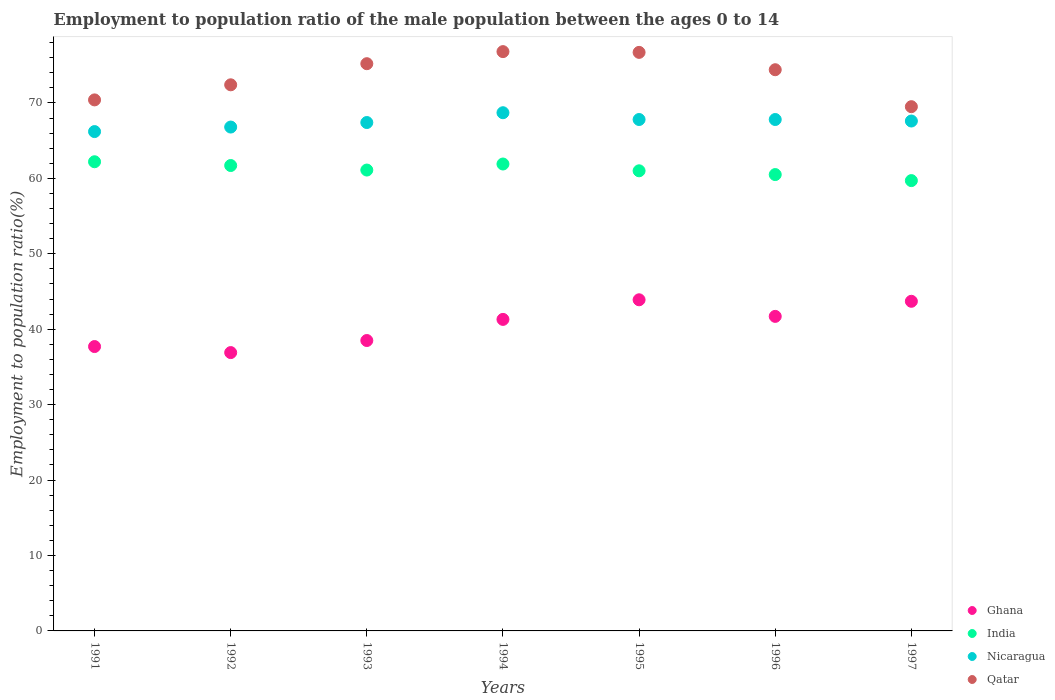How many different coloured dotlines are there?
Provide a short and direct response. 4. Is the number of dotlines equal to the number of legend labels?
Ensure brevity in your answer.  Yes. What is the employment to population ratio in Nicaragua in 1993?
Make the answer very short. 67.4. Across all years, what is the maximum employment to population ratio in Ghana?
Your response must be concise. 43.9. Across all years, what is the minimum employment to population ratio in Qatar?
Provide a succinct answer. 69.5. In which year was the employment to population ratio in India maximum?
Offer a terse response. 1991. In which year was the employment to population ratio in Ghana minimum?
Offer a very short reply. 1992. What is the total employment to population ratio in India in the graph?
Give a very brief answer. 428.1. What is the difference between the employment to population ratio in Qatar in 1992 and that in 1993?
Your response must be concise. -2.8. What is the difference between the employment to population ratio in Qatar in 1994 and the employment to population ratio in Ghana in 1997?
Provide a short and direct response. 33.1. What is the average employment to population ratio in Nicaragua per year?
Provide a short and direct response. 67.47. In the year 1997, what is the difference between the employment to population ratio in Ghana and employment to population ratio in India?
Give a very brief answer. -16. In how many years, is the employment to population ratio in Ghana greater than 4 %?
Keep it short and to the point. 7. What is the ratio of the employment to population ratio in Ghana in 1992 to that in 1994?
Your response must be concise. 0.89. Is the employment to population ratio in India in 1993 less than that in 1997?
Give a very brief answer. No. Is the difference between the employment to population ratio in Ghana in 1992 and 1996 greater than the difference between the employment to population ratio in India in 1992 and 1996?
Keep it short and to the point. No. What is the difference between the highest and the second highest employment to population ratio in Qatar?
Give a very brief answer. 0.1. Does the employment to population ratio in India monotonically increase over the years?
Your answer should be very brief. No. Is the employment to population ratio in Nicaragua strictly less than the employment to population ratio in Ghana over the years?
Your answer should be compact. No. What is the difference between two consecutive major ticks on the Y-axis?
Your answer should be compact. 10. Are the values on the major ticks of Y-axis written in scientific E-notation?
Your answer should be compact. No. Does the graph contain any zero values?
Your answer should be very brief. No. Does the graph contain grids?
Your answer should be compact. No. How many legend labels are there?
Offer a terse response. 4. How are the legend labels stacked?
Give a very brief answer. Vertical. What is the title of the graph?
Offer a terse response. Employment to population ratio of the male population between the ages 0 to 14. What is the label or title of the X-axis?
Ensure brevity in your answer.  Years. What is the label or title of the Y-axis?
Offer a very short reply. Employment to population ratio(%). What is the Employment to population ratio(%) of Ghana in 1991?
Offer a very short reply. 37.7. What is the Employment to population ratio(%) in India in 1991?
Your answer should be compact. 62.2. What is the Employment to population ratio(%) of Nicaragua in 1991?
Your answer should be compact. 66.2. What is the Employment to population ratio(%) in Qatar in 1991?
Your answer should be compact. 70.4. What is the Employment to population ratio(%) in Ghana in 1992?
Your answer should be compact. 36.9. What is the Employment to population ratio(%) in India in 1992?
Make the answer very short. 61.7. What is the Employment to population ratio(%) in Nicaragua in 1992?
Provide a short and direct response. 66.8. What is the Employment to population ratio(%) in Qatar in 1992?
Keep it short and to the point. 72.4. What is the Employment to population ratio(%) in Ghana in 1993?
Offer a very short reply. 38.5. What is the Employment to population ratio(%) of India in 1993?
Your answer should be compact. 61.1. What is the Employment to population ratio(%) in Nicaragua in 1993?
Your answer should be compact. 67.4. What is the Employment to population ratio(%) in Qatar in 1993?
Keep it short and to the point. 75.2. What is the Employment to population ratio(%) of Ghana in 1994?
Provide a short and direct response. 41.3. What is the Employment to population ratio(%) of India in 1994?
Make the answer very short. 61.9. What is the Employment to population ratio(%) in Nicaragua in 1994?
Offer a very short reply. 68.7. What is the Employment to population ratio(%) of Qatar in 1994?
Ensure brevity in your answer.  76.8. What is the Employment to population ratio(%) of Ghana in 1995?
Offer a terse response. 43.9. What is the Employment to population ratio(%) in Nicaragua in 1995?
Your answer should be compact. 67.8. What is the Employment to population ratio(%) in Qatar in 1995?
Keep it short and to the point. 76.7. What is the Employment to population ratio(%) in Ghana in 1996?
Provide a succinct answer. 41.7. What is the Employment to population ratio(%) of India in 1996?
Give a very brief answer. 60.5. What is the Employment to population ratio(%) of Nicaragua in 1996?
Ensure brevity in your answer.  67.8. What is the Employment to population ratio(%) of Qatar in 1996?
Offer a very short reply. 74.4. What is the Employment to population ratio(%) of Ghana in 1997?
Make the answer very short. 43.7. What is the Employment to population ratio(%) in India in 1997?
Offer a very short reply. 59.7. What is the Employment to population ratio(%) in Nicaragua in 1997?
Give a very brief answer. 67.6. What is the Employment to population ratio(%) in Qatar in 1997?
Your answer should be compact. 69.5. Across all years, what is the maximum Employment to population ratio(%) in Ghana?
Your answer should be very brief. 43.9. Across all years, what is the maximum Employment to population ratio(%) in India?
Provide a short and direct response. 62.2. Across all years, what is the maximum Employment to population ratio(%) in Nicaragua?
Make the answer very short. 68.7. Across all years, what is the maximum Employment to population ratio(%) of Qatar?
Provide a succinct answer. 76.8. Across all years, what is the minimum Employment to population ratio(%) in Ghana?
Your response must be concise. 36.9. Across all years, what is the minimum Employment to population ratio(%) of India?
Provide a succinct answer. 59.7. Across all years, what is the minimum Employment to population ratio(%) in Nicaragua?
Provide a short and direct response. 66.2. Across all years, what is the minimum Employment to population ratio(%) of Qatar?
Provide a short and direct response. 69.5. What is the total Employment to population ratio(%) in Ghana in the graph?
Offer a terse response. 283.7. What is the total Employment to population ratio(%) of India in the graph?
Make the answer very short. 428.1. What is the total Employment to population ratio(%) of Nicaragua in the graph?
Ensure brevity in your answer.  472.3. What is the total Employment to population ratio(%) of Qatar in the graph?
Provide a succinct answer. 515.4. What is the difference between the Employment to population ratio(%) in Ghana in 1991 and that in 1992?
Make the answer very short. 0.8. What is the difference between the Employment to population ratio(%) in Nicaragua in 1991 and that in 1992?
Your response must be concise. -0.6. What is the difference between the Employment to population ratio(%) in Qatar in 1991 and that in 1992?
Offer a very short reply. -2. What is the difference between the Employment to population ratio(%) of Ghana in 1991 and that in 1993?
Give a very brief answer. -0.8. What is the difference between the Employment to population ratio(%) of India in 1991 and that in 1993?
Give a very brief answer. 1.1. What is the difference between the Employment to population ratio(%) of Nicaragua in 1991 and that in 1993?
Your response must be concise. -1.2. What is the difference between the Employment to population ratio(%) in India in 1991 and that in 1994?
Provide a short and direct response. 0.3. What is the difference between the Employment to population ratio(%) of Nicaragua in 1991 and that in 1994?
Give a very brief answer. -2.5. What is the difference between the Employment to population ratio(%) in Ghana in 1991 and that in 1995?
Your answer should be very brief. -6.2. What is the difference between the Employment to population ratio(%) of India in 1991 and that in 1995?
Offer a very short reply. 1.2. What is the difference between the Employment to population ratio(%) of Nicaragua in 1991 and that in 1995?
Provide a short and direct response. -1.6. What is the difference between the Employment to population ratio(%) of Qatar in 1991 and that in 1996?
Offer a very short reply. -4. What is the difference between the Employment to population ratio(%) in Ghana in 1991 and that in 1997?
Your response must be concise. -6. What is the difference between the Employment to population ratio(%) in Nicaragua in 1991 and that in 1997?
Your response must be concise. -1.4. What is the difference between the Employment to population ratio(%) in Qatar in 1991 and that in 1997?
Make the answer very short. 0.9. What is the difference between the Employment to population ratio(%) of India in 1992 and that in 1993?
Give a very brief answer. 0.6. What is the difference between the Employment to population ratio(%) in Nicaragua in 1992 and that in 1993?
Make the answer very short. -0.6. What is the difference between the Employment to population ratio(%) in Ghana in 1992 and that in 1994?
Your answer should be very brief. -4.4. What is the difference between the Employment to population ratio(%) of Nicaragua in 1992 and that in 1994?
Your answer should be very brief. -1.9. What is the difference between the Employment to population ratio(%) of Ghana in 1992 and that in 1995?
Offer a very short reply. -7. What is the difference between the Employment to population ratio(%) of India in 1992 and that in 1995?
Make the answer very short. 0.7. What is the difference between the Employment to population ratio(%) in Qatar in 1992 and that in 1995?
Keep it short and to the point. -4.3. What is the difference between the Employment to population ratio(%) in India in 1992 and that in 1996?
Give a very brief answer. 1.2. What is the difference between the Employment to population ratio(%) of Nicaragua in 1992 and that in 1996?
Your response must be concise. -1. What is the difference between the Employment to population ratio(%) in Nicaragua in 1992 and that in 1997?
Ensure brevity in your answer.  -0.8. What is the difference between the Employment to population ratio(%) of Ghana in 1993 and that in 1994?
Give a very brief answer. -2.8. What is the difference between the Employment to population ratio(%) in India in 1993 and that in 1994?
Your answer should be compact. -0.8. What is the difference between the Employment to population ratio(%) in Nicaragua in 1993 and that in 1994?
Offer a very short reply. -1.3. What is the difference between the Employment to population ratio(%) of Qatar in 1993 and that in 1994?
Your answer should be compact. -1.6. What is the difference between the Employment to population ratio(%) in India in 1993 and that in 1995?
Your response must be concise. 0.1. What is the difference between the Employment to population ratio(%) in Nicaragua in 1993 and that in 1995?
Offer a terse response. -0.4. What is the difference between the Employment to population ratio(%) in Ghana in 1993 and that in 1996?
Make the answer very short. -3.2. What is the difference between the Employment to population ratio(%) in India in 1993 and that in 1996?
Your response must be concise. 0.6. What is the difference between the Employment to population ratio(%) in Qatar in 1993 and that in 1996?
Ensure brevity in your answer.  0.8. What is the difference between the Employment to population ratio(%) in Ghana in 1993 and that in 1997?
Provide a succinct answer. -5.2. What is the difference between the Employment to population ratio(%) of Qatar in 1993 and that in 1997?
Give a very brief answer. 5.7. What is the difference between the Employment to population ratio(%) in Ghana in 1994 and that in 1995?
Your answer should be compact. -2.6. What is the difference between the Employment to population ratio(%) of Nicaragua in 1994 and that in 1995?
Ensure brevity in your answer.  0.9. What is the difference between the Employment to population ratio(%) in Ghana in 1994 and that in 1996?
Give a very brief answer. -0.4. What is the difference between the Employment to population ratio(%) in Nicaragua in 1994 and that in 1996?
Give a very brief answer. 0.9. What is the difference between the Employment to population ratio(%) of Qatar in 1994 and that in 1997?
Make the answer very short. 7.3. What is the difference between the Employment to population ratio(%) of Ghana in 1995 and that in 1996?
Provide a short and direct response. 2.2. What is the difference between the Employment to population ratio(%) of Qatar in 1995 and that in 1996?
Provide a succinct answer. 2.3. What is the difference between the Employment to population ratio(%) in India in 1995 and that in 1997?
Your response must be concise. 1.3. What is the difference between the Employment to population ratio(%) in Nicaragua in 1995 and that in 1997?
Give a very brief answer. 0.2. What is the difference between the Employment to population ratio(%) of Nicaragua in 1996 and that in 1997?
Give a very brief answer. 0.2. What is the difference between the Employment to population ratio(%) in Qatar in 1996 and that in 1997?
Keep it short and to the point. 4.9. What is the difference between the Employment to population ratio(%) in Ghana in 1991 and the Employment to population ratio(%) in India in 1992?
Give a very brief answer. -24. What is the difference between the Employment to population ratio(%) of Ghana in 1991 and the Employment to population ratio(%) of Nicaragua in 1992?
Ensure brevity in your answer.  -29.1. What is the difference between the Employment to population ratio(%) in Ghana in 1991 and the Employment to population ratio(%) in Qatar in 1992?
Ensure brevity in your answer.  -34.7. What is the difference between the Employment to population ratio(%) in India in 1991 and the Employment to population ratio(%) in Qatar in 1992?
Provide a short and direct response. -10.2. What is the difference between the Employment to population ratio(%) in Nicaragua in 1991 and the Employment to population ratio(%) in Qatar in 1992?
Your answer should be compact. -6.2. What is the difference between the Employment to population ratio(%) in Ghana in 1991 and the Employment to population ratio(%) in India in 1993?
Ensure brevity in your answer.  -23.4. What is the difference between the Employment to population ratio(%) in Ghana in 1991 and the Employment to population ratio(%) in Nicaragua in 1993?
Keep it short and to the point. -29.7. What is the difference between the Employment to population ratio(%) in Ghana in 1991 and the Employment to population ratio(%) in Qatar in 1993?
Offer a terse response. -37.5. What is the difference between the Employment to population ratio(%) in Ghana in 1991 and the Employment to population ratio(%) in India in 1994?
Ensure brevity in your answer.  -24.2. What is the difference between the Employment to population ratio(%) in Ghana in 1991 and the Employment to population ratio(%) in Nicaragua in 1994?
Make the answer very short. -31. What is the difference between the Employment to population ratio(%) of Ghana in 1991 and the Employment to population ratio(%) of Qatar in 1994?
Give a very brief answer. -39.1. What is the difference between the Employment to population ratio(%) of India in 1991 and the Employment to population ratio(%) of Qatar in 1994?
Offer a terse response. -14.6. What is the difference between the Employment to population ratio(%) of Nicaragua in 1991 and the Employment to population ratio(%) of Qatar in 1994?
Make the answer very short. -10.6. What is the difference between the Employment to population ratio(%) in Ghana in 1991 and the Employment to population ratio(%) in India in 1995?
Offer a very short reply. -23.3. What is the difference between the Employment to population ratio(%) in Ghana in 1991 and the Employment to population ratio(%) in Nicaragua in 1995?
Make the answer very short. -30.1. What is the difference between the Employment to population ratio(%) in Ghana in 1991 and the Employment to population ratio(%) in Qatar in 1995?
Keep it short and to the point. -39. What is the difference between the Employment to population ratio(%) of India in 1991 and the Employment to population ratio(%) of Nicaragua in 1995?
Keep it short and to the point. -5.6. What is the difference between the Employment to population ratio(%) of Ghana in 1991 and the Employment to population ratio(%) of India in 1996?
Provide a succinct answer. -22.8. What is the difference between the Employment to population ratio(%) of Ghana in 1991 and the Employment to population ratio(%) of Nicaragua in 1996?
Provide a short and direct response. -30.1. What is the difference between the Employment to population ratio(%) in Ghana in 1991 and the Employment to population ratio(%) in Qatar in 1996?
Give a very brief answer. -36.7. What is the difference between the Employment to population ratio(%) of India in 1991 and the Employment to population ratio(%) of Qatar in 1996?
Provide a succinct answer. -12.2. What is the difference between the Employment to population ratio(%) in Nicaragua in 1991 and the Employment to population ratio(%) in Qatar in 1996?
Your response must be concise. -8.2. What is the difference between the Employment to population ratio(%) of Ghana in 1991 and the Employment to population ratio(%) of Nicaragua in 1997?
Keep it short and to the point. -29.9. What is the difference between the Employment to population ratio(%) in Ghana in 1991 and the Employment to population ratio(%) in Qatar in 1997?
Offer a very short reply. -31.8. What is the difference between the Employment to population ratio(%) in India in 1991 and the Employment to population ratio(%) in Qatar in 1997?
Give a very brief answer. -7.3. What is the difference between the Employment to population ratio(%) in Ghana in 1992 and the Employment to population ratio(%) in India in 1993?
Offer a terse response. -24.2. What is the difference between the Employment to population ratio(%) of Ghana in 1992 and the Employment to population ratio(%) of Nicaragua in 1993?
Your response must be concise. -30.5. What is the difference between the Employment to population ratio(%) of Ghana in 1992 and the Employment to population ratio(%) of Qatar in 1993?
Make the answer very short. -38.3. What is the difference between the Employment to population ratio(%) of India in 1992 and the Employment to population ratio(%) of Nicaragua in 1993?
Give a very brief answer. -5.7. What is the difference between the Employment to population ratio(%) in India in 1992 and the Employment to population ratio(%) in Qatar in 1993?
Your answer should be compact. -13.5. What is the difference between the Employment to population ratio(%) of Nicaragua in 1992 and the Employment to population ratio(%) of Qatar in 1993?
Provide a short and direct response. -8.4. What is the difference between the Employment to population ratio(%) in Ghana in 1992 and the Employment to population ratio(%) in Nicaragua in 1994?
Ensure brevity in your answer.  -31.8. What is the difference between the Employment to population ratio(%) in Ghana in 1992 and the Employment to population ratio(%) in Qatar in 1994?
Provide a succinct answer. -39.9. What is the difference between the Employment to population ratio(%) in India in 1992 and the Employment to population ratio(%) in Qatar in 1994?
Ensure brevity in your answer.  -15.1. What is the difference between the Employment to population ratio(%) of Nicaragua in 1992 and the Employment to population ratio(%) of Qatar in 1994?
Offer a terse response. -10. What is the difference between the Employment to population ratio(%) of Ghana in 1992 and the Employment to population ratio(%) of India in 1995?
Offer a terse response. -24.1. What is the difference between the Employment to population ratio(%) in Ghana in 1992 and the Employment to population ratio(%) in Nicaragua in 1995?
Ensure brevity in your answer.  -30.9. What is the difference between the Employment to population ratio(%) of Ghana in 1992 and the Employment to population ratio(%) of Qatar in 1995?
Offer a very short reply. -39.8. What is the difference between the Employment to population ratio(%) of Ghana in 1992 and the Employment to population ratio(%) of India in 1996?
Keep it short and to the point. -23.6. What is the difference between the Employment to population ratio(%) of Ghana in 1992 and the Employment to population ratio(%) of Nicaragua in 1996?
Offer a terse response. -30.9. What is the difference between the Employment to population ratio(%) in Ghana in 1992 and the Employment to population ratio(%) in Qatar in 1996?
Your answer should be very brief. -37.5. What is the difference between the Employment to population ratio(%) in India in 1992 and the Employment to population ratio(%) in Nicaragua in 1996?
Provide a short and direct response. -6.1. What is the difference between the Employment to population ratio(%) of Ghana in 1992 and the Employment to population ratio(%) of India in 1997?
Offer a very short reply. -22.8. What is the difference between the Employment to population ratio(%) in Ghana in 1992 and the Employment to population ratio(%) in Nicaragua in 1997?
Make the answer very short. -30.7. What is the difference between the Employment to population ratio(%) of Ghana in 1992 and the Employment to population ratio(%) of Qatar in 1997?
Your answer should be very brief. -32.6. What is the difference between the Employment to population ratio(%) in India in 1992 and the Employment to population ratio(%) in Qatar in 1997?
Provide a short and direct response. -7.8. What is the difference between the Employment to population ratio(%) in Ghana in 1993 and the Employment to population ratio(%) in India in 1994?
Offer a very short reply. -23.4. What is the difference between the Employment to population ratio(%) in Ghana in 1993 and the Employment to population ratio(%) in Nicaragua in 1994?
Keep it short and to the point. -30.2. What is the difference between the Employment to population ratio(%) in Ghana in 1993 and the Employment to population ratio(%) in Qatar in 1994?
Ensure brevity in your answer.  -38.3. What is the difference between the Employment to population ratio(%) of India in 1993 and the Employment to population ratio(%) of Nicaragua in 1994?
Give a very brief answer. -7.6. What is the difference between the Employment to population ratio(%) in India in 1993 and the Employment to population ratio(%) in Qatar in 1994?
Your response must be concise. -15.7. What is the difference between the Employment to population ratio(%) in Ghana in 1993 and the Employment to population ratio(%) in India in 1995?
Your response must be concise. -22.5. What is the difference between the Employment to population ratio(%) of Ghana in 1993 and the Employment to population ratio(%) of Nicaragua in 1995?
Your answer should be compact. -29.3. What is the difference between the Employment to population ratio(%) of Ghana in 1993 and the Employment to population ratio(%) of Qatar in 1995?
Provide a short and direct response. -38.2. What is the difference between the Employment to population ratio(%) of India in 1993 and the Employment to population ratio(%) of Qatar in 1995?
Offer a terse response. -15.6. What is the difference between the Employment to population ratio(%) in Ghana in 1993 and the Employment to population ratio(%) in Nicaragua in 1996?
Offer a very short reply. -29.3. What is the difference between the Employment to population ratio(%) in Ghana in 1993 and the Employment to population ratio(%) in Qatar in 1996?
Offer a very short reply. -35.9. What is the difference between the Employment to population ratio(%) in India in 1993 and the Employment to population ratio(%) in Qatar in 1996?
Your response must be concise. -13.3. What is the difference between the Employment to population ratio(%) of Ghana in 1993 and the Employment to population ratio(%) of India in 1997?
Offer a very short reply. -21.2. What is the difference between the Employment to population ratio(%) of Ghana in 1993 and the Employment to population ratio(%) of Nicaragua in 1997?
Provide a succinct answer. -29.1. What is the difference between the Employment to population ratio(%) of Ghana in 1993 and the Employment to population ratio(%) of Qatar in 1997?
Provide a succinct answer. -31. What is the difference between the Employment to population ratio(%) of India in 1993 and the Employment to population ratio(%) of Nicaragua in 1997?
Your answer should be very brief. -6.5. What is the difference between the Employment to population ratio(%) in Ghana in 1994 and the Employment to population ratio(%) in India in 1995?
Keep it short and to the point. -19.7. What is the difference between the Employment to population ratio(%) in Ghana in 1994 and the Employment to population ratio(%) in Nicaragua in 1995?
Provide a short and direct response. -26.5. What is the difference between the Employment to population ratio(%) of Ghana in 1994 and the Employment to population ratio(%) of Qatar in 1995?
Provide a succinct answer. -35.4. What is the difference between the Employment to population ratio(%) in India in 1994 and the Employment to population ratio(%) in Nicaragua in 1995?
Your answer should be compact. -5.9. What is the difference between the Employment to population ratio(%) of India in 1994 and the Employment to population ratio(%) of Qatar in 1995?
Your answer should be compact. -14.8. What is the difference between the Employment to population ratio(%) in Ghana in 1994 and the Employment to population ratio(%) in India in 1996?
Provide a short and direct response. -19.2. What is the difference between the Employment to population ratio(%) of Ghana in 1994 and the Employment to population ratio(%) of Nicaragua in 1996?
Offer a very short reply. -26.5. What is the difference between the Employment to population ratio(%) in Ghana in 1994 and the Employment to population ratio(%) in Qatar in 1996?
Ensure brevity in your answer.  -33.1. What is the difference between the Employment to population ratio(%) of India in 1994 and the Employment to population ratio(%) of Nicaragua in 1996?
Give a very brief answer. -5.9. What is the difference between the Employment to population ratio(%) in Ghana in 1994 and the Employment to population ratio(%) in India in 1997?
Offer a terse response. -18.4. What is the difference between the Employment to population ratio(%) of Ghana in 1994 and the Employment to population ratio(%) of Nicaragua in 1997?
Your answer should be compact. -26.3. What is the difference between the Employment to population ratio(%) of Ghana in 1994 and the Employment to population ratio(%) of Qatar in 1997?
Ensure brevity in your answer.  -28.2. What is the difference between the Employment to population ratio(%) in India in 1994 and the Employment to population ratio(%) in Nicaragua in 1997?
Your response must be concise. -5.7. What is the difference between the Employment to population ratio(%) in Ghana in 1995 and the Employment to population ratio(%) in India in 1996?
Ensure brevity in your answer.  -16.6. What is the difference between the Employment to population ratio(%) of Ghana in 1995 and the Employment to population ratio(%) of Nicaragua in 1996?
Offer a terse response. -23.9. What is the difference between the Employment to population ratio(%) in Ghana in 1995 and the Employment to population ratio(%) in Qatar in 1996?
Make the answer very short. -30.5. What is the difference between the Employment to population ratio(%) of Ghana in 1995 and the Employment to population ratio(%) of India in 1997?
Your response must be concise. -15.8. What is the difference between the Employment to population ratio(%) in Ghana in 1995 and the Employment to population ratio(%) in Nicaragua in 1997?
Ensure brevity in your answer.  -23.7. What is the difference between the Employment to population ratio(%) of Ghana in 1995 and the Employment to population ratio(%) of Qatar in 1997?
Ensure brevity in your answer.  -25.6. What is the difference between the Employment to population ratio(%) of India in 1995 and the Employment to population ratio(%) of Nicaragua in 1997?
Keep it short and to the point. -6.6. What is the difference between the Employment to population ratio(%) of Nicaragua in 1995 and the Employment to population ratio(%) of Qatar in 1997?
Offer a very short reply. -1.7. What is the difference between the Employment to population ratio(%) of Ghana in 1996 and the Employment to population ratio(%) of Nicaragua in 1997?
Your answer should be compact. -25.9. What is the difference between the Employment to population ratio(%) of Ghana in 1996 and the Employment to population ratio(%) of Qatar in 1997?
Your answer should be compact. -27.8. What is the difference between the Employment to population ratio(%) of India in 1996 and the Employment to population ratio(%) of Qatar in 1997?
Make the answer very short. -9. What is the difference between the Employment to population ratio(%) of Nicaragua in 1996 and the Employment to population ratio(%) of Qatar in 1997?
Your answer should be compact. -1.7. What is the average Employment to population ratio(%) of Ghana per year?
Ensure brevity in your answer.  40.53. What is the average Employment to population ratio(%) of India per year?
Your answer should be very brief. 61.16. What is the average Employment to population ratio(%) in Nicaragua per year?
Keep it short and to the point. 67.47. What is the average Employment to population ratio(%) in Qatar per year?
Offer a terse response. 73.63. In the year 1991, what is the difference between the Employment to population ratio(%) of Ghana and Employment to population ratio(%) of India?
Your response must be concise. -24.5. In the year 1991, what is the difference between the Employment to population ratio(%) in Ghana and Employment to population ratio(%) in Nicaragua?
Your answer should be very brief. -28.5. In the year 1991, what is the difference between the Employment to population ratio(%) of Ghana and Employment to population ratio(%) of Qatar?
Keep it short and to the point. -32.7. In the year 1992, what is the difference between the Employment to population ratio(%) of Ghana and Employment to population ratio(%) of India?
Offer a terse response. -24.8. In the year 1992, what is the difference between the Employment to population ratio(%) of Ghana and Employment to population ratio(%) of Nicaragua?
Your answer should be very brief. -29.9. In the year 1992, what is the difference between the Employment to population ratio(%) of Ghana and Employment to population ratio(%) of Qatar?
Your response must be concise. -35.5. In the year 1992, what is the difference between the Employment to population ratio(%) of Nicaragua and Employment to population ratio(%) of Qatar?
Ensure brevity in your answer.  -5.6. In the year 1993, what is the difference between the Employment to population ratio(%) in Ghana and Employment to population ratio(%) in India?
Provide a short and direct response. -22.6. In the year 1993, what is the difference between the Employment to population ratio(%) of Ghana and Employment to population ratio(%) of Nicaragua?
Give a very brief answer. -28.9. In the year 1993, what is the difference between the Employment to population ratio(%) of Ghana and Employment to population ratio(%) of Qatar?
Offer a very short reply. -36.7. In the year 1993, what is the difference between the Employment to population ratio(%) in India and Employment to population ratio(%) in Nicaragua?
Give a very brief answer. -6.3. In the year 1993, what is the difference between the Employment to population ratio(%) in India and Employment to population ratio(%) in Qatar?
Offer a very short reply. -14.1. In the year 1994, what is the difference between the Employment to population ratio(%) in Ghana and Employment to population ratio(%) in India?
Give a very brief answer. -20.6. In the year 1994, what is the difference between the Employment to population ratio(%) of Ghana and Employment to population ratio(%) of Nicaragua?
Provide a succinct answer. -27.4. In the year 1994, what is the difference between the Employment to population ratio(%) in Ghana and Employment to population ratio(%) in Qatar?
Offer a terse response. -35.5. In the year 1994, what is the difference between the Employment to population ratio(%) of India and Employment to population ratio(%) of Nicaragua?
Ensure brevity in your answer.  -6.8. In the year 1994, what is the difference between the Employment to population ratio(%) of India and Employment to population ratio(%) of Qatar?
Keep it short and to the point. -14.9. In the year 1995, what is the difference between the Employment to population ratio(%) in Ghana and Employment to population ratio(%) in India?
Your response must be concise. -17.1. In the year 1995, what is the difference between the Employment to population ratio(%) of Ghana and Employment to population ratio(%) of Nicaragua?
Keep it short and to the point. -23.9. In the year 1995, what is the difference between the Employment to population ratio(%) of Ghana and Employment to population ratio(%) of Qatar?
Ensure brevity in your answer.  -32.8. In the year 1995, what is the difference between the Employment to population ratio(%) in India and Employment to population ratio(%) in Nicaragua?
Your response must be concise. -6.8. In the year 1995, what is the difference between the Employment to population ratio(%) in India and Employment to population ratio(%) in Qatar?
Keep it short and to the point. -15.7. In the year 1995, what is the difference between the Employment to population ratio(%) in Nicaragua and Employment to population ratio(%) in Qatar?
Provide a succinct answer. -8.9. In the year 1996, what is the difference between the Employment to population ratio(%) in Ghana and Employment to population ratio(%) in India?
Offer a very short reply. -18.8. In the year 1996, what is the difference between the Employment to population ratio(%) of Ghana and Employment to population ratio(%) of Nicaragua?
Give a very brief answer. -26.1. In the year 1996, what is the difference between the Employment to population ratio(%) in Ghana and Employment to population ratio(%) in Qatar?
Ensure brevity in your answer.  -32.7. In the year 1996, what is the difference between the Employment to population ratio(%) of India and Employment to population ratio(%) of Nicaragua?
Your answer should be very brief. -7.3. In the year 1996, what is the difference between the Employment to population ratio(%) in India and Employment to population ratio(%) in Qatar?
Offer a terse response. -13.9. In the year 1996, what is the difference between the Employment to population ratio(%) in Nicaragua and Employment to population ratio(%) in Qatar?
Keep it short and to the point. -6.6. In the year 1997, what is the difference between the Employment to population ratio(%) in Ghana and Employment to population ratio(%) in Nicaragua?
Your answer should be very brief. -23.9. In the year 1997, what is the difference between the Employment to population ratio(%) of Ghana and Employment to population ratio(%) of Qatar?
Make the answer very short. -25.8. In the year 1997, what is the difference between the Employment to population ratio(%) in India and Employment to population ratio(%) in Qatar?
Keep it short and to the point. -9.8. What is the ratio of the Employment to population ratio(%) in Ghana in 1991 to that in 1992?
Offer a very short reply. 1.02. What is the ratio of the Employment to population ratio(%) in India in 1991 to that in 1992?
Offer a very short reply. 1.01. What is the ratio of the Employment to population ratio(%) in Nicaragua in 1991 to that in 1992?
Keep it short and to the point. 0.99. What is the ratio of the Employment to population ratio(%) in Qatar in 1991 to that in 1992?
Offer a very short reply. 0.97. What is the ratio of the Employment to population ratio(%) of Ghana in 1991 to that in 1993?
Provide a short and direct response. 0.98. What is the ratio of the Employment to population ratio(%) in India in 1991 to that in 1993?
Give a very brief answer. 1.02. What is the ratio of the Employment to population ratio(%) of Nicaragua in 1991 to that in 1993?
Provide a succinct answer. 0.98. What is the ratio of the Employment to population ratio(%) in Qatar in 1991 to that in 1993?
Offer a very short reply. 0.94. What is the ratio of the Employment to population ratio(%) in Ghana in 1991 to that in 1994?
Ensure brevity in your answer.  0.91. What is the ratio of the Employment to population ratio(%) of India in 1991 to that in 1994?
Provide a succinct answer. 1. What is the ratio of the Employment to population ratio(%) in Nicaragua in 1991 to that in 1994?
Offer a terse response. 0.96. What is the ratio of the Employment to population ratio(%) of Qatar in 1991 to that in 1994?
Keep it short and to the point. 0.92. What is the ratio of the Employment to population ratio(%) in Ghana in 1991 to that in 1995?
Your answer should be very brief. 0.86. What is the ratio of the Employment to population ratio(%) of India in 1991 to that in 1995?
Give a very brief answer. 1.02. What is the ratio of the Employment to population ratio(%) of Nicaragua in 1991 to that in 1995?
Your answer should be compact. 0.98. What is the ratio of the Employment to population ratio(%) in Qatar in 1991 to that in 1995?
Your answer should be compact. 0.92. What is the ratio of the Employment to population ratio(%) in Ghana in 1991 to that in 1996?
Make the answer very short. 0.9. What is the ratio of the Employment to population ratio(%) of India in 1991 to that in 1996?
Give a very brief answer. 1.03. What is the ratio of the Employment to population ratio(%) in Nicaragua in 1991 to that in 1996?
Provide a succinct answer. 0.98. What is the ratio of the Employment to population ratio(%) of Qatar in 1991 to that in 1996?
Your response must be concise. 0.95. What is the ratio of the Employment to population ratio(%) in Ghana in 1991 to that in 1997?
Make the answer very short. 0.86. What is the ratio of the Employment to population ratio(%) in India in 1991 to that in 1997?
Your answer should be very brief. 1.04. What is the ratio of the Employment to population ratio(%) in Nicaragua in 1991 to that in 1997?
Provide a short and direct response. 0.98. What is the ratio of the Employment to population ratio(%) of Qatar in 1991 to that in 1997?
Keep it short and to the point. 1.01. What is the ratio of the Employment to population ratio(%) of Ghana in 1992 to that in 1993?
Offer a terse response. 0.96. What is the ratio of the Employment to population ratio(%) of India in 1992 to that in 1993?
Offer a very short reply. 1.01. What is the ratio of the Employment to population ratio(%) of Qatar in 1992 to that in 1993?
Your answer should be very brief. 0.96. What is the ratio of the Employment to population ratio(%) in Ghana in 1992 to that in 1994?
Your response must be concise. 0.89. What is the ratio of the Employment to population ratio(%) of India in 1992 to that in 1994?
Give a very brief answer. 1. What is the ratio of the Employment to population ratio(%) in Nicaragua in 1992 to that in 1994?
Keep it short and to the point. 0.97. What is the ratio of the Employment to population ratio(%) in Qatar in 1992 to that in 1994?
Offer a very short reply. 0.94. What is the ratio of the Employment to population ratio(%) of Ghana in 1992 to that in 1995?
Your answer should be compact. 0.84. What is the ratio of the Employment to population ratio(%) of India in 1992 to that in 1995?
Make the answer very short. 1.01. What is the ratio of the Employment to population ratio(%) in Nicaragua in 1992 to that in 1995?
Keep it short and to the point. 0.99. What is the ratio of the Employment to population ratio(%) of Qatar in 1992 to that in 1995?
Offer a very short reply. 0.94. What is the ratio of the Employment to population ratio(%) of Ghana in 1992 to that in 1996?
Your response must be concise. 0.88. What is the ratio of the Employment to population ratio(%) of India in 1992 to that in 1996?
Provide a short and direct response. 1.02. What is the ratio of the Employment to population ratio(%) in Nicaragua in 1992 to that in 1996?
Your response must be concise. 0.99. What is the ratio of the Employment to population ratio(%) in Qatar in 1992 to that in 1996?
Provide a succinct answer. 0.97. What is the ratio of the Employment to population ratio(%) of Ghana in 1992 to that in 1997?
Give a very brief answer. 0.84. What is the ratio of the Employment to population ratio(%) in India in 1992 to that in 1997?
Provide a succinct answer. 1.03. What is the ratio of the Employment to population ratio(%) of Qatar in 1992 to that in 1997?
Keep it short and to the point. 1.04. What is the ratio of the Employment to population ratio(%) in Ghana in 1993 to that in 1994?
Make the answer very short. 0.93. What is the ratio of the Employment to population ratio(%) of India in 1993 to that in 1994?
Make the answer very short. 0.99. What is the ratio of the Employment to population ratio(%) of Nicaragua in 1993 to that in 1994?
Make the answer very short. 0.98. What is the ratio of the Employment to population ratio(%) in Qatar in 1993 to that in 1994?
Your response must be concise. 0.98. What is the ratio of the Employment to population ratio(%) of Ghana in 1993 to that in 1995?
Provide a succinct answer. 0.88. What is the ratio of the Employment to population ratio(%) in Qatar in 1993 to that in 1995?
Make the answer very short. 0.98. What is the ratio of the Employment to population ratio(%) in Ghana in 1993 to that in 1996?
Make the answer very short. 0.92. What is the ratio of the Employment to population ratio(%) of India in 1993 to that in 1996?
Provide a short and direct response. 1.01. What is the ratio of the Employment to population ratio(%) of Qatar in 1993 to that in 1996?
Provide a short and direct response. 1.01. What is the ratio of the Employment to population ratio(%) in Ghana in 1993 to that in 1997?
Make the answer very short. 0.88. What is the ratio of the Employment to population ratio(%) of India in 1993 to that in 1997?
Ensure brevity in your answer.  1.02. What is the ratio of the Employment to population ratio(%) of Qatar in 1993 to that in 1997?
Give a very brief answer. 1.08. What is the ratio of the Employment to population ratio(%) in Ghana in 1994 to that in 1995?
Your answer should be compact. 0.94. What is the ratio of the Employment to population ratio(%) in India in 1994 to that in 1995?
Provide a succinct answer. 1.01. What is the ratio of the Employment to population ratio(%) of Nicaragua in 1994 to that in 1995?
Provide a short and direct response. 1.01. What is the ratio of the Employment to population ratio(%) of Ghana in 1994 to that in 1996?
Offer a terse response. 0.99. What is the ratio of the Employment to population ratio(%) of India in 1994 to that in 1996?
Your answer should be very brief. 1.02. What is the ratio of the Employment to population ratio(%) in Nicaragua in 1994 to that in 1996?
Make the answer very short. 1.01. What is the ratio of the Employment to population ratio(%) in Qatar in 1994 to that in 1996?
Give a very brief answer. 1.03. What is the ratio of the Employment to population ratio(%) in Ghana in 1994 to that in 1997?
Give a very brief answer. 0.95. What is the ratio of the Employment to population ratio(%) of India in 1994 to that in 1997?
Provide a succinct answer. 1.04. What is the ratio of the Employment to population ratio(%) in Nicaragua in 1994 to that in 1997?
Make the answer very short. 1.02. What is the ratio of the Employment to population ratio(%) of Qatar in 1994 to that in 1997?
Provide a short and direct response. 1.1. What is the ratio of the Employment to population ratio(%) in Ghana in 1995 to that in 1996?
Offer a very short reply. 1.05. What is the ratio of the Employment to population ratio(%) of India in 1995 to that in 1996?
Offer a terse response. 1.01. What is the ratio of the Employment to population ratio(%) of Qatar in 1995 to that in 1996?
Your answer should be very brief. 1.03. What is the ratio of the Employment to population ratio(%) in Ghana in 1995 to that in 1997?
Give a very brief answer. 1. What is the ratio of the Employment to population ratio(%) of India in 1995 to that in 1997?
Your answer should be very brief. 1.02. What is the ratio of the Employment to population ratio(%) in Qatar in 1995 to that in 1997?
Offer a terse response. 1.1. What is the ratio of the Employment to population ratio(%) of Ghana in 1996 to that in 1997?
Keep it short and to the point. 0.95. What is the ratio of the Employment to population ratio(%) in India in 1996 to that in 1997?
Ensure brevity in your answer.  1.01. What is the ratio of the Employment to population ratio(%) in Nicaragua in 1996 to that in 1997?
Your response must be concise. 1. What is the ratio of the Employment to population ratio(%) in Qatar in 1996 to that in 1997?
Make the answer very short. 1.07. What is the difference between the highest and the second highest Employment to population ratio(%) in Ghana?
Offer a terse response. 0.2. What is the difference between the highest and the second highest Employment to population ratio(%) of Nicaragua?
Offer a terse response. 0.9. What is the difference between the highest and the second highest Employment to population ratio(%) of Qatar?
Offer a terse response. 0.1. What is the difference between the highest and the lowest Employment to population ratio(%) in Ghana?
Ensure brevity in your answer.  7. What is the difference between the highest and the lowest Employment to population ratio(%) of India?
Provide a succinct answer. 2.5. What is the difference between the highest and the lowest Employment to population ratio(%) of Nicaragua?
Ensure brevity in your answer.  2.5. What is the difference between the highest and the lowest Employment to population ratio(%) in Qatar?
Keep it short and to the point. 7.3. 